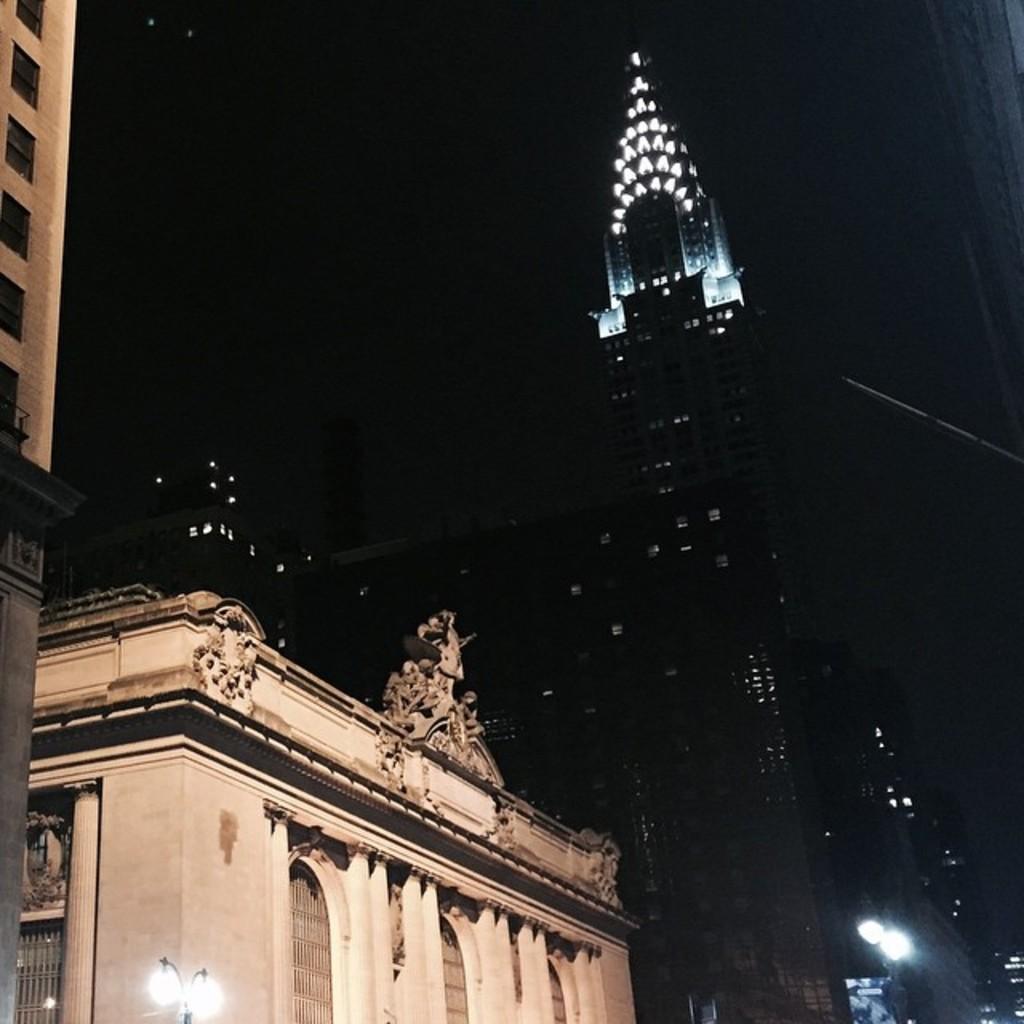Describe this image in one or two sentences. The picture consists of buildings, skyscrapers, lights and street lights. 